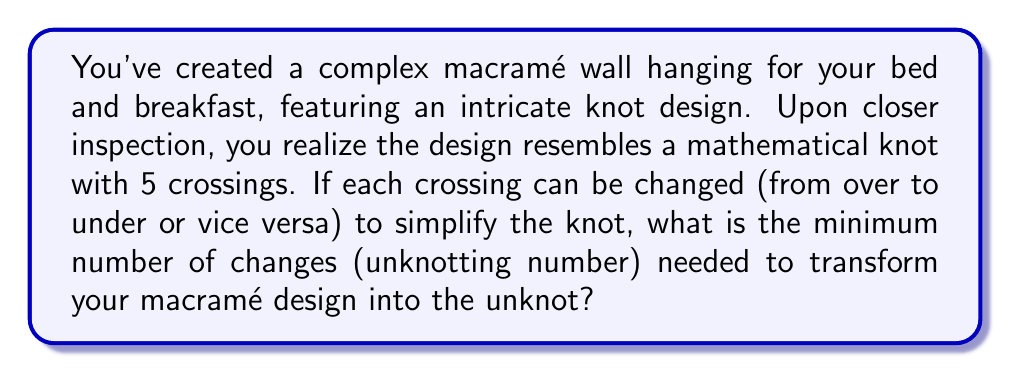Can you solve this math problem? To solve this problem, we need to understand the concept of unknotting number and apply it to the given macramé design. Let's break it down step-by-step:

1. The unknotting number of a knot is the minimum number of crossing changes required to transform the knot into the unknot (a simple closed loop with no crossings).

2. For a knot with 5 crossings, the maximum possible unknotting number is 5, as changing all crossings would certainly unknot it.

3. However, the minimum unknotting number is often less than the total number of crossings. We need to consider the most efficient way to simplify the knot.

4. For a 5-crossing knot, there are several possibilities:
   a) It could be a trivial knot (unknotting number 0)
   b) It could be a trefoil knot (unknotting number 1)
   c) It could be a figure-eight knot (unknotting number 1)
   d) It could be a 5_1 or 5_2 knot (unknotting number 2)

5. Without more specific information about the exact configuration of the macramé design, we can assume it's one of the more complex 5-crossing knots (5_1 or 5_2).

6. Both 5_1 and 5_2 knots have an unknotting number of 2.

Therefore, the minimum number of changes needed to transform the macramé design into the unknot is likely 2.
Answer: 2 